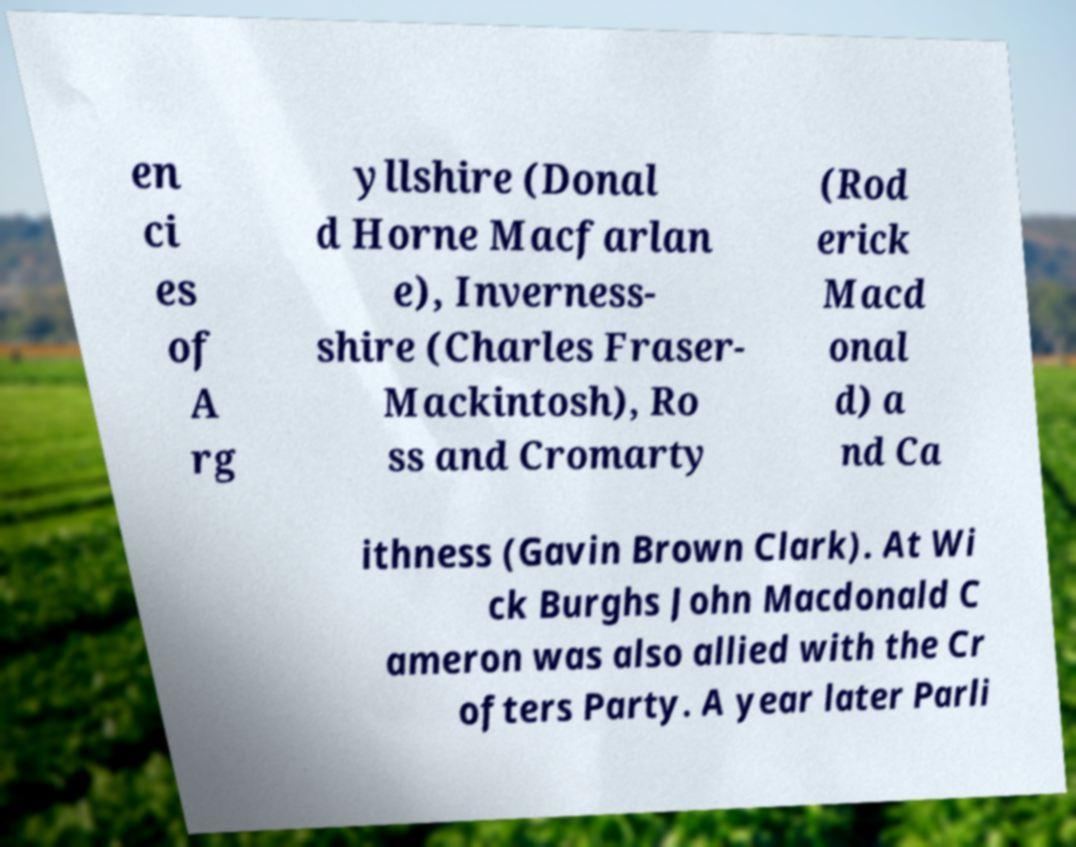Please read and relay the text visible in this image. What does it say? en ci es of A rg yllshire (Donal d Horne Macfarlan e), Inverness- shire (Charles Fraser- Mackintosh), Ro ss and Cromarty (Rod erick Macd onal d) a nd Ca ithness (Gavin Brown Clark). At Wi ck Burghs John Macdonald C ameron was also allied with the Cr ofters Party. A year later Parli 